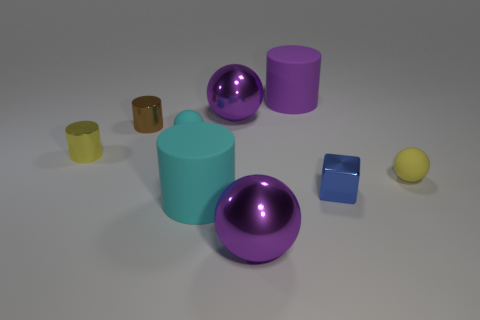Subtract all small yellow cylinders. How many cylinders are left? 3 Add 1 yellow metal cylinders. How many objects exist? 10 Subtract all purple cylinders. How many cylinders are left? 3 Subtract all spheres. How many objects are left? 5 Subtract 1 cubes. How many cubes are left? 0 Subtract all red cylinders. Subtract all cyan spheres. How many cylinders are left? 4 Subtract all purple cylinders. How many cyan spheres are left? 1 Subtract all cubes. Subtract all yellow cylinders. How many objects are left? 7 Add 4 balls. How many balls are left? 8 Add 5 matte things. How many matte things exist? 9 